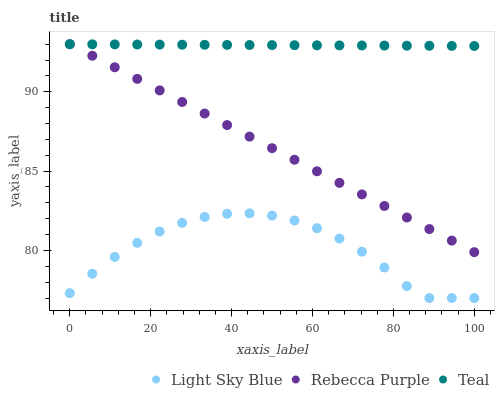Does Light Sky Blue have the minimum area under the curve?
Answer yes or no. Yes. Does Teal have the maximum area under the curve?
Answer yes or no. Yes. Does Rebecca Purple have the minimum area under the curve?
Answer yes or no. No. Does Rebecca Purple have the maximum area under the curve?
Answer yes or no. No. Is Rebecca Purple the smoothest?
Answer yes or no. Yes. Is Light Sky Blue the roughest?
Answer yes or no. Yes. Is Teal the smoothest?
Answer yes or no. No. Is Teal the roughest?
Answer yes or no. No. Does Light Sky Blue have the lowest value?
Answer yes or no. Yes. Does Rebecca Purple have the lowest value?
Answer yes or no. No. Does Teal have the highest value?
Answer yes or no. Yes. Is Light Sky Blue less than Rebecca Purple?
Answer yes or no. Yes. Is Rebecca Purple greater than Light Sky Blue?
Answer yes or no. Yes. Does Teal intersect Rebecca Purple?
Answer yes or no. Yes. Is Teal less than Rebecca Purple?
Answer yes or no. No. Is Teal greater than Rebecca Purple?
Answer yes or no. No. Does Light Sky Blue intersect Rebecca Purple?
Answer yes or no. No. 